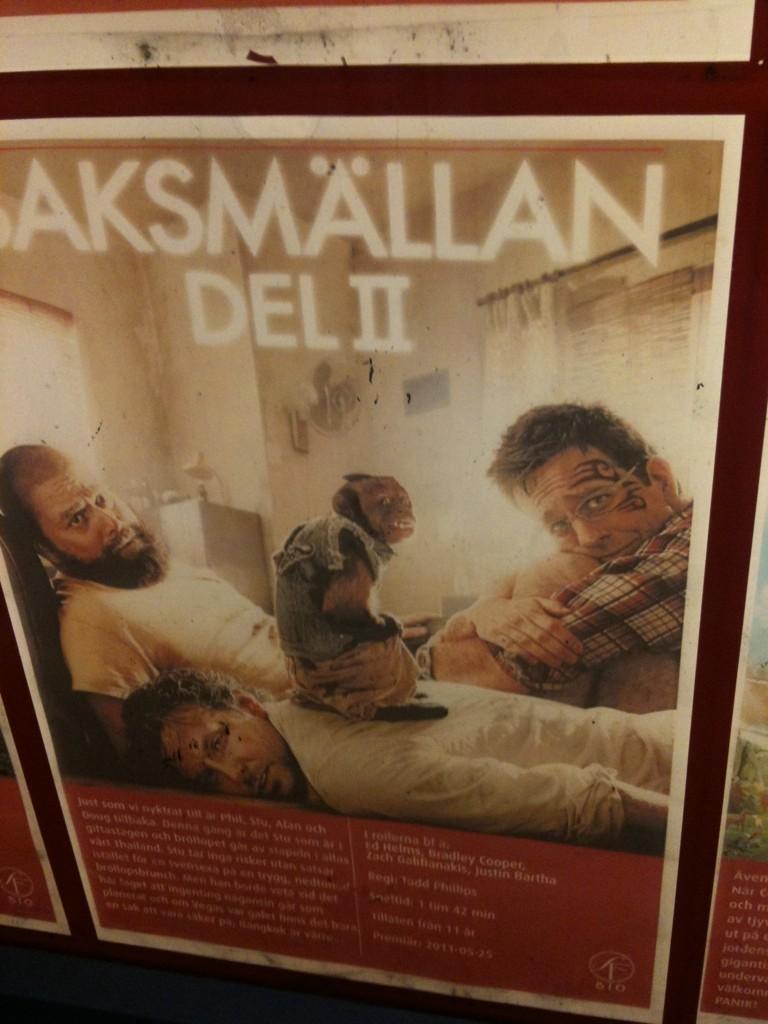In one or two sentences, can you explain what this image depicts? In this picture we can see a wall poster here, in this poster we can see three men, a wall and some text. 